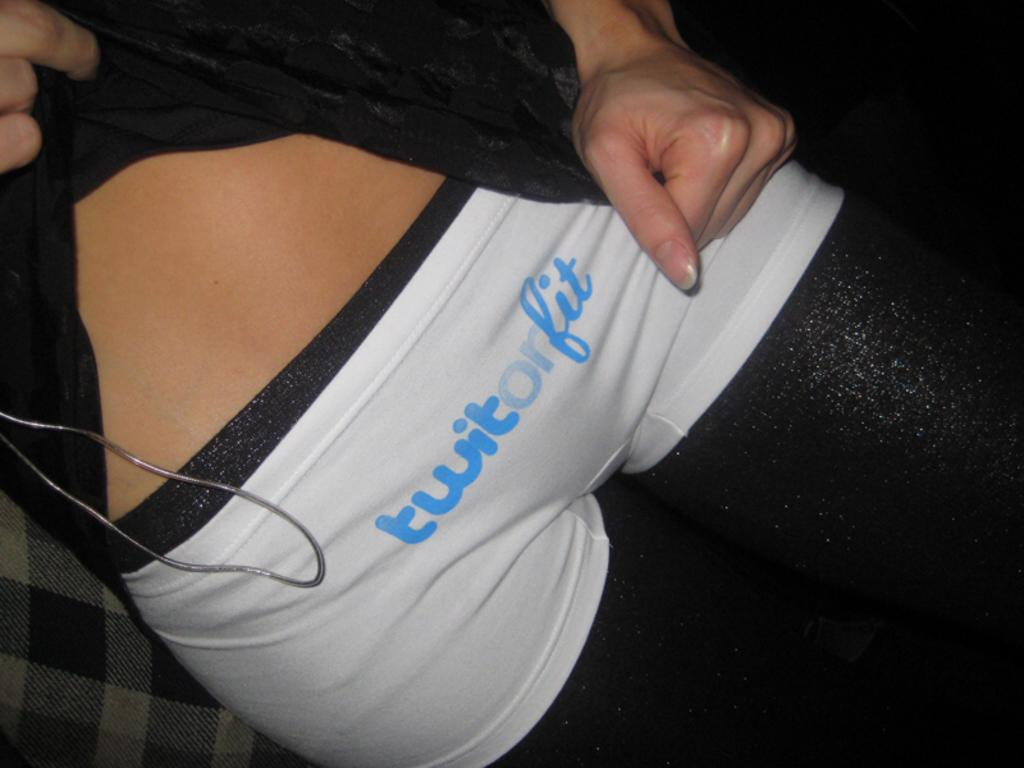Provide a one-sentence caption for the provided image. a person showing off white shorts with the words Twit or Fit on them. 